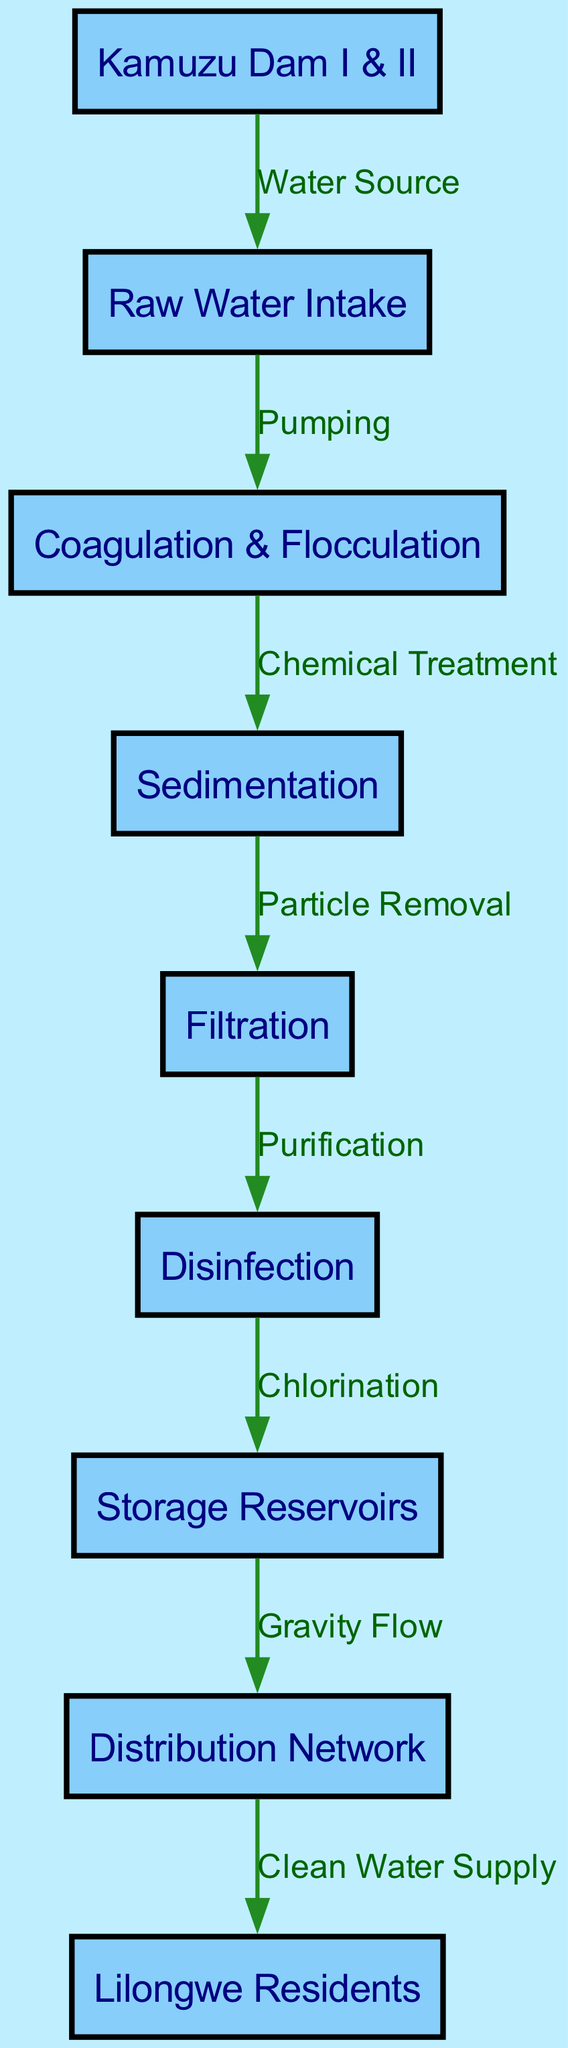What is the first node in the flowchart? The first node in the flowchart is "Kamuzu Dam I & II," which serves as the starting point of the water treatment process.
Answer: Kamuzu Dam I & II How many nodes are in the diagram? Counting all the nodes listed, there are nine nodes in total that represent different stages of the water treatment and distribution process.
Answer: 9 What is the label of the last node? The last node in the flowchart is labeled "Lilongwe Residents," indicating the final destination of the treated water.
Answer: Lilongwe Residents Which process occurs after "Filtration"? The process that follows "Filtration" in the flowchart is "Disinfection," where the water is purified before storage.
Answer: Disinfection What type of flow occurs between "Storage Reservoirs" and "Distribution Network"? The flow between "Storage Reservoirs" and "Distribution Network" is described as "Gravity Flow," highlighting the natural movement of water from storage to distribution.
Answer: Gravity Flow What action takes place between "Raw Water Intake" and "Coagulation & Flocculation"? The action that occurs between these two nodes is "Pumping," which is necessary to move the raw water into treatment processes.
Answer: Pumping How does water reach the residents from the storage reservoirs? Water reaches the residents from the storage reservoirs through the distribution network, which is responsible for supplying clean water to the community.
Answer: Distribution Network Which treatment method is applied after "Sedimentation"? After "Sedimentation," the treatment method applied is "Filtration," focusing on removing remaining particles from the water.
Answer: Filtration What is the purpose of the "Disinfection" stage? The purpose of the "Disinfection" stage is to ensure the water is safe by killing any harmful pathogens before it is stored.
Answer: Purification 